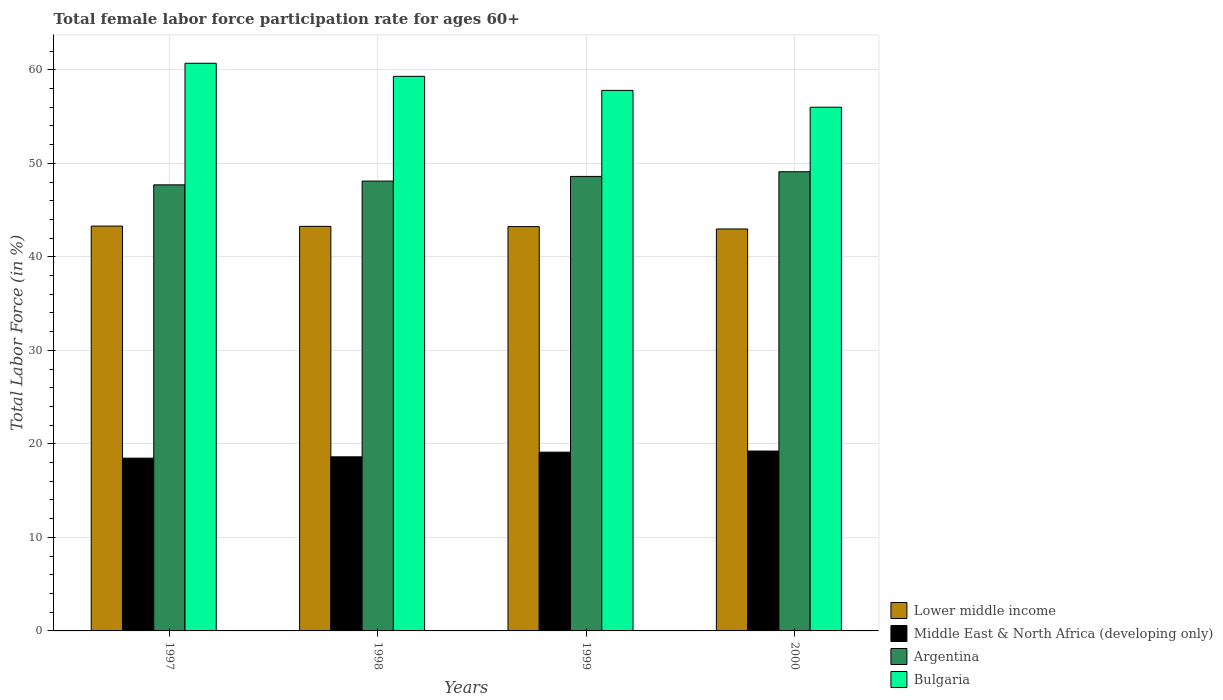How many different coloured bars are there?
Offer a very short reply. 4. Are the number of bars per tick equal to the number of legend labels?
Keep it short and to the point. Yes. How many bars are there on the 1st tick from the left?
Ensure brevity in your answer.  4. How many bars are there on the 4th tick from the right?
Ensure brevity in your answer.  4. What is the label of the 3rd group of bars from the left?
Ensure brevity in your answer.  1999. In how many cases, is the number of bars for a given year not equal to the number of legend labels?
Ensure brevity in your answer.  0. What is the female labor force participation rate in Middle East & North Africa (developing only) in 1998?
Keep it short and to the point. 18.62. Across all years, what is the maximum female labor force participation rate in Argentina?
Ensure brevity in your answer.  49.1. Across all years, what is the minimum female labor force participation rate in Lower middle income?
Ensure brevity in your answer.  42.98. In which year was the female labor force participation rate in Argentina minimum?
Ensure brevity in your answer.  1997. What is the total female labor force participation rate in Argentina in the graph?
Keep it short and to the point. 193.5. What is the difference between the female labor force participation rate in Lower middle income in 1998 and that in 2000?
Provide a succinct answer. 0.28. What is the difference between the female labor force participation rate in Argentina in 1998 and the female labor force participation rate in Lower middle income in 1997?
Provide a short and direct response. 4.81. What is the average female labor force participation rate in Bulgaria per year?
Offer a terse response. 58.45. In the year 2000, what is the difference between the female labor force participation rate in Bulgaria and female labor force participation rate in Lower middle income?
Ensure brevity in your answer.  13.02. In how many years, is the female labor force participation rate in Middle East & North Africa (developing only) greater than 16 %?
Offer a very short reply. 4. What is the ratio of the female labor force participation rate in Middle East & North Africa (developing only) in 1999 to that in 2000?
Make the answer very short. 0.99. What is the difference between the highest and the second highest female labor force participation rate in Argentina?
Provide a short and direct response. 0.5. What is the difference between the highest and the lowest female labor force participation rate in Argentina?
Offer a very short reply. 1.4. In how many years, is the female labor force participation rate in Lower middle income greater than the average female labor force participation rate in Lower middle income taken over all years?
Your answer should be very brief. 3. What does the 1st bar from the right in 1999 represents?
Ensure brevity in your answer.  Bulgaria. How many bars are there?
Provide a succinct answer. 16. Are all the bars in the graph horizontal?
Give a very brief answer. No. How many years are there in the graph?
Provide a succinct answer. 4. What is the difference between two consecutive major ticks on the Y-axis?
Offer a terse response. 10. Does the graph contain any zero values?
Give a very brief answer. No. Where does the legend appear in the graph?
Your answer should be very brief. Bottom right. How are the legend labels stacked?
Make the answer very short. Vertical. What is the title of the graph?
Keep it short and to the point. Total female labor force participation rate for ages 60+. Does "Vanuatu" appear as one of the legend labels in the graph?
Ensure brevity in your answer.  No. What is the label or title of the Y-axis?
Offer a very short reply. Total Labor Force (in %). What is the Total Labor Force (in %) in Lower middle income in 1997?
Your answer should be compact. 43.29. What is the Total Labor Force (in %) in Middle East & North Africa (developing only) in 1997?
Offer a very short reply. 18.47. What is the Total Labor Force (in %) of Argentina in 1997?
Your response must be concise. 47.7. What is the Total Labor Force (in %) in Bulgaria in 1997?
Offer a terse response. 60.7. What is the Total Labor Force (in %) of Lower middle income in 1998?
Provide a succinct answer. 43.26. What is the Total Labor Force (in %) in Middle East & North Africa (developing only) in 1998?
Offer a very short reply. 18.62. What is the Total Labor Force (in %) in Argentina in 1998?
Provide a succinct answer. 48.1. What is the Total Labor Force (in %) of Bulgaria in 1998?
Offer a very short reply. 59.3. What is the Total Labor Force (in %) of Lower middle income in 1999?
Provide a succinct answer. 43.23. What is the Total Labor Force (in %) in Middle East & North Africa (developing only) in 1999?
Keep it short and to the point. 19.11. What is the Total Labor Force (in %) in Argentina in 1999?
Offer a very short reply. 48.6. What is the Total Labor Force (in %) of Bulgaria in 1999?
Your answer should be very brief. 57.8. What is the Total Labor Force (in %) of Lower middle income in 2000?
Your response must be concise. 42.98. What is the Total Labor Force (in %) of Middle East & North Africa (developing only) in 2000?
Your response must be concise. 19.24. What is the Total Labor Force (in %) in Argentina in 2000?
Your response must be concise. 49.1. What is the Total Labor Force (in %) in Bulgaria in 2000?
Provide a short and direct response. 56. Across all years, what is the maximum Total Labor Force (in %) in Lower middle income?
Ensure brevity in your answer.  43.29. Across all years, what is the maximum Total Labor Force (in %) of Middle East & North Africa (developing only)?
Keep it short and to the point. 19.24. Across all years, what is the maximum Total Labor Force (in %) in Argentina?
Give a very brief answer. 49.1. Across all years, what is the maximum Total Labor Force (in %) in Bulgaria?
Ensure brevity in your answer.  60.7. Across all years, what is the minimum Total Labor Force (in %) in Lower middle income?
Keep it short and to the point. 42.98. Across all years, what is the minimum Total Labor Force (in %) in Middle East & North Africa (developing only)?
Provide a short and direct response. 18.47. Across all years, what is the minimum Total Labor Force (in %) of Argentina?
Provide a succinct answer. 47.7. What is the total Total Labor Force (in %) in Lower middle income in the graph?
Keep it short and to the point. 172.77. What is the total Total Labor Force (in %) of Middle East & North Africa (developing only) in the graph?
Give a very brief answer. 75.44. What is the total Total Labor Force (in %) of Argentina in the graph?
Your answer should be very brief. 193.5. What is the total Total Labor Force (in %) of Bulgaria in the graph?
Your answer should be very brief. 233.8. What is the difference between the Total Labor Force (in %) of Lower middle income in 1997 and that in 1998?
Give a very brief answer. 0.03. What is the difference between the Total Labor Force (in %) of Middle East & North Africa (developing only) in 1997 and that in 1998?
Keep it short and to the point. -0.14. What is the difference between the Total Labor Force (in %) of Lower middle income in 1997 and that in 1999?
Ensure brevity in your answer.  0.06. What is the difference between the Total Labor Force (in %) in Middle East & North Africa (developing only) in 1997 and that in 1999?
Your response must be concise. -0.64. What is the difference between the Total Labor Force (in %) of Argentina in 1997 and that in 1999?
Offer a very short reply. -0.9. What is the difference between the Total Labor Force (in %) in Bulgaria in 1997 and that in 1999?
Your answer should be very brief. 2.9. What is the difference between the Total Labor Force (in %) of Lower middle income in 1997 and that in 2000?
Provide a succinct answer. 0.31. What is the difference between the Total Labor Force (in %) of Middle East & North Africa (developing only) in 1997 and that in 2000?
Keep it short and to the point. -0.76. What is the difference between the Total Labor Force (in %) of Bulgaria in 1997 and that in 2000?
Keep it short and to the point. 4.7. What is the difference between the Total Labor Force (in %) of Lower middle income in 1998 and that in 1999?
Your answer should be very brief. 0.03. What is the difference between the Total Labor Force (in %) of Middle East & North Africa (developing only) in 1998 and that in 1999?
Offer a terse response. -0.5. What is the difference between the Total Labor Force (in %) in Bulgaria in 1998 and that in 1999?
Offer a terse response. 1.5. What is the difference between the Total Labor Force (in %) of Lower middle income in 1998 and that in 2000?
Give a very brief answer. 0.28. What is the difference between the Total Labor Force (in %) of Middle East & North Africa (developing only) in 1998 and that in 2000?
Ensure brevity in your answer.  -0.62. What is the difference between the Total Labor Force (in %) of Argentina in 1998 and that in 2000?
Your response must be concise. -1. What is the difference between the Total Labor Force (in %) in Lower middle income in 1999 and that in 2000?
Offer a terse response. 0.25. What is the difference between the Total Labor Force (in %) of Middle East & North Africa (developing only) in 1999 and that in 2000?
Give a very brief answer. -0.12. What is the difference between the Total Labor Force (in %) of Bulgaria in 1999 and that in 2000?
Offer a very short reply. 1.8. What is the difference between the Total Labor Force (in %) in Lower middle income in 1997 and the Total Labor Force (in %) in Middle East & North Africa (developing only) in 1998?
Your answer should be compact. 24.67. What is the difference between the Total Labor Force (in %) of Lower middle income in 1997 and the Total Labor Force (in %) of Argentina in 1998?
Your answer should be very brief. -4.81. What is the difference between the Total Labor Force (in %) of Lower middle income in 1997 and the Total Labor Force (in %) of Bulgaria in 1998?
Provide a succinct answer. -16.01. What is the difference between the Total Labor Force (in %) of Middle East & North Africa (developing only) in 1997 and the Total Labor Force (in %) of Argentina in 1998?
Make the answer very short. -29.63. What is the difference between the Total Labor Force (in %) in Middle East & North Africa (developing only) in 1997 and the Total Labor Force (in %) in Bulgaria in 1998?
Your response must be concise. -40.83. What is the difference between the Total Labor Force (in %) in Lower middle income in 1997 and the Total Labor Force (in %) in Middle East & North Africa (developing only) in 1999?
Offer a terse response. 24.18. What is the difference between the Total Labor Force (in %) of Lower middle income in 1997 and the Total Labor Force (in %) of Argentina in 1999?
Offer a terse response. -5.31. What is the difference between the Total Labor Force (in %) of Lower middle income in 1997 and the Total Labor Force (in %) of Bulgaria in 1999?
Offer a very short reply. -14.51. What is the difference between the Total Labor Force (in %) in Middle East & North Africa (developing only) in 1997 and the Total Labor Force (in %) in Argentina in 1999?
Provide a short and direct response. -30.13. What is the difference between the Total Labor Force (in %) of Middle East & North Africa (developing only) in 1997 and the Total Labor Force (in %) of Bulgaria in 1999?
Your answer should be compact. -39.33. What is the difference between the Total Labor Force (in %) in Argentina in 1997 and the Total Labor Force (in %) in Bulgaria in 1999?
Keep it short and to the point. -10.1. What is the difference between the Total Labor Force (in %) in Lower middle income in 1997 and the Total Labor Force (in %) in Middle East & North Africa (developing only) in 2000?
Provide a short and direct response. 24.05. What is the difference between the Total Labor Force (in %) of Lower middle income in 1997 and the Total Labor Force (in %) of Argentina in 2000?
Offer a very short reply. -5.81. What is the difference between the Total Labor Force (in %) of Lower middle income in 1997 and the Total Labor Force (in %) of Bulgaria in 2000?
Your answer should be compact. -12.71. What is the difference between the Total Labor Force (in %) of Middle East & North Africa (developing only) in 1997 and the Total Labor Force (in %) of Argentina in 2000?
Give a very brief answer. -30.63. What is the difference between the Total Labor Force (in %) in Middle East & North Africa (developing only) in 1997 and the Total Labor Force (in %) in Bulgaria in 2000?
Your response must be concise. -37.53. What is the difference between the Total Labor Force (in %) of Lower middle income in 1998 and the Total Labor Force (in %) of Middle East & North Africa (developing only) in 1999?
Ensure brevity in your answer.  24.15. What is the difference between the Total Labor Force (in %) in Lower middle income in 1998 and the Total Labor Force (in %) in Argentina in 1999?
Provide a short and direct response. -5.34. What is the difference between the Total Labor Force (in %) of Lower middle income in 1998 and the Total Labor Force (in %) of Bulgaria in 1999?
Offer a very short reply. -14.54. What is the difference between the Total Labor Force (in %) in Middle East & North Africa (developing only) in 1998 and the Total Labor Force (in %) in Argentina in 1999?
Offer a very short reply. -29.98. What is the difference between the Total Labor Force (in %) of Middle East & North Africa (developing only) in 1998 and the Total Labor Force (in %) of Bulgaria in 1999?
Make the answer very short. -39.18. What is the difference between the Total Labor Force (in %) in Lower middle income in 1998 and the Total Labor Force (in %) in Middle East & North Africa (developing only) in 2000?
Your answer should be compact. 24.03. What is the difference between the Total Labor Force (in %) of Lower middle income in 1998 and the Total Labor Force (in %) of Argentina in 2000?
Provide a succinct answer. -5.84. What is the difference between the Total Labor Force (in %) in Lower middle income in 1998 and the Total Labor Force (in %) in Bulgaria in 2000?
Offer a very short reply. -12.74. What is the difference between the Total Labor Force (in %) in Middle East & North Africa (developing only) in 1998 and the Total Labor Force (in %) in Argentina in 2000?
Give a very brief answer. -30.48. What is the difference between the Total Labor Force (in %) in Middle East & North Africa (developing only) in 1998 and the Total Labor Force (in %) in Bulgaria in 2000?
Offer a terse response. -37.38. What is the difference between the Total Labor Force (in %) in Argentina in 1998 and the Total Labor Force (in %) in Bulgaria in 2000?
Offer a very short reply. -7.9. What is the difference between the Total Labor Force (in %) in Lower middle income in 1999 and the Total Labor Force (in %) in Middle East & North Africa (developing only) in 2000?
Make the answer very short. 24. What is the difference between the Total Labor Force (in %) in Lower middle income in 1999 and the Total Labor Force (in %) in Argentina in 2000?
Keep it short and to the point. -5.87. What is the difference between the Total Labor Force (in %) in Lower middle income in 1999 and the Total Labor Force (in %) in Bulgaria in 2000?
Provide a short and direct response. -12.77. What is the difference between the Total Labor Force (in %) in Middle East & North Africa (developing only) in 1999 and the Total Labor Force (in %) in Argentina in 2000?
Your answer should be very brief. -29.99. What is the difference between the Total Labor Force (in %) of Middle East & North Africa (developing only) in 1999 and the Total Labor Force (in %) of Bulgaria in 2000?
Offer a terse response. -36.89. What is the average Total Labor Force (in %) in Lower middle income per year?
Make the answer very short. 43.19. What is the average Total Labor Force (in %) of Middle East & North Africa (developing only) per year?
Your answer should be very brief. 18.86. What is the average Total Labor Force (in %) in Argentina per year?
Your answer should be very brief. 48.38. What is the average Total Labor Force (in %) in Bulgaria per year?
Your response must be concise. 58.45. In the year 1997, what is the difference between the Total Labor Force (in %) in Lower middle income and Total Labor Force (in %) in Middle East & North Africa (developing only)?
Keep it short and to the point. 24.82. In the year 1997, what is the difference between the Total Labor Force (in %) in Lower middle income and Total Labor Force (in %) in Argentina?
Provide a succinct answer. -4.41. In the year 1997, what is the difference between the Total Labor Force (in %) of Lower middle income and Total Labor Force (in %) of Bulgaria?
Your response must be concise. -17.41. In the year 1997, what is the difference between the Total Labor Force (in %) in Middle East & North Africa (developing only) and Total Labor Force (in %) in Argentina?
Your answer should be very brief. -29.23. In the year 1997, what is the difference between the Total Labor Force (in %) of Middle East & North Africa (developing only) and Total Labor Force (in %) of Bulgaria?
Offer a very short reply. -42.23. In the year 1997, what is the difference between the Total Labor Force (in %) of Argentina and Total Labor Force (in %) of Bulgaria?
Provide a short and direct response. -13. In the year 1998, what is the difference between the Total Labor Force (in %) of Lower middle income and Total Labor Force (in %) of Middle East & North Africa (developing only)?
Provide a succinct answer. 24.64. In the year 1998, what is the difference between the Total Labor Force (in %) of Lower middle income and Total Labor Force (in %) of Argentina?
Offer a terse response. -4.84. In the year 1998, what is the difference between the Total Labor Force (in %) in Lower middle income and Total Labor Force (in %) in Bulgaria?
Offer a terse response. -16.04. In the year 1998, what is the difference between the Total Labor Force (in %) of Middle East & North Africa (developing only) and Total Labor Force (in %) of Argentina?
Your response must be concise. -29.48. In the year 1998, what is the difference between the Total Labor Force (in %) in Middle East & North Africa (developing only) and Total Labor Force (in %) in Bulgaria?
Make the answer very short. -40.68. In the year 1998, what is the difference between the Total Labor Force (in %) in Argentina and Total Labor Force (in %) in Bulgaria?
Make the answer very short. -11.2. In the year 1999, what is the difference between the Total Labor Force (in %) in Lower middle income and Total Labor Force (in %) in Middle East & North Africa (developing only)?
Your answer should be very brief. 24.12. In the year 1999, what is the difference between the Total Labor Force (in %) of Lower middle income and Total Labor Force (in %) of Argentina?
Ensure brevity in your answer.  -5.37. In the year 1999, what is the difference between the Total Labor Force (in %) in Lower middle income and Total Labor Force (in %) in Bulgaria?
Provide a short and direct response. -14.57. In the year 1999, what is the difference between the Total Labor Force (in %) of Middle East & North Africa (developing only) and Total Labor Force (in %) of Argentina?
Make the answer very short. -29.49. In the year 1999, what is the difference between the Total Labor Force (in %) in Middle East & North Africa (developing only) and Total Labor Force (in %) in Bulgaria?
Ensure brevity in your answer.  -38.69. In the year 2000, what is the difference between the Total Labor Force (in %) of Lower middle income and Total Labor Force (in %) of Middle East & North Africa (developing only)?
Provide a succinct answer. 23.75. In the year 2000, what is the difference between the Total Labor Force (in %) of Lower middle income and Total Labor Force (in %) of Argentina?
Ensure brevity in your answer.  -6.12. In the year 2000, what is the difference between the Total Labor Force (in %) of Lower middle income and Total Labor Force (in %) of Bulgaria?
Make the answer very short. -13.02. In the year 2000, what is the difference between the Total Labor Force (in %) in Middle East & North Africa (developing only) and Total Labor Force (in %) in Argentina?
Provide a short and direct response. -29.86. In the year 2000, what is the difference between the Total Labor Force (in %) of Middle East & North Africa (developing only) and Total Labor Force (in %) of Bulgaria?
Your answer should be compact. -36.76. In the year 2000, what is the difference between the Total Labor Force (in %) in Argentina and Total Labor Force (in %) in Bulgaria?
Give a very brief answer. -6.9. What is the ratio of the Total Labor Force (in %) in Lower middle income in 1997 to that in 1998?
Offer a very short reply. 1. What is the ratio of the Total Labor Force (in %) of Argentina in 1997 to that in 1998?
Keep it short and to the point. 0.99. What is the ratio of the Total Labor Force (in %) of Bulgaria in 1997 to that in 1998?
Give a very brief answer. 1.02. What is the ratio of the Total Labor Force (in %) in Lower middle income in 1997 to that in 1999?
Provide a short and direct response. 1. What is the ratio of the Total Labor Force (in %) of Middle East & North Africa (developing only) in 1997 to that in 1999?
Keep it short and to the point. 0.97. What is the ratio of the Total Labor Force (in %) in Argentina in 1997 to that in 1999?
Offer a terse response. 0.98. What is the ratio of the Total Labor Force (in %) in Bulgaria in 1997 to that in 1999?
Provide a short and direct response. 1.05. What is the ratio of the Total Labor Force (in %) in Middle East & North Africa (developing only) in 1997 to that in 2000?
Your response must be concise. 0.96. What is the ratio of the Total Labor Force (in %) in Argentina in 1997 to that in 2000?
Your answer should be very brief. 0.97. What is the ratio of the Total Labor Force (in %) of Bulgaria in 1997 to that in 2000?
Offer a very short reply. 1.08. What is the ratio of the Total Labor Force (in %) in Argentina in 1998 to that in 1999?
Your answer should be compact. 0.99. What is the ratio of the Total Labor Force (in %) in Middle East & North Africa (developing only) in 1998 to that in 2000?
Offer a terse response. 0.97. What is the ratio of the Total Labor Force (in %) of Argentina in 1998 to that in 2000?
Your response must be concise. 0.98. What is the ratio of the Total Labor Force (in %) in Bulgaria in 1998 to that in 2000?
Give a very brief answer. 1.06. What is the ratio of the Total Labor Force (in %) in Lower middle income in 1999 to that in 2000?
Your response must be concise. 1.01. What is the ratio of the Total Labor Force (in %) of Middle East & North Africa (developing only) in 1999 to that in 2000?
Make the answer very short. 0.99. What is the ratio of the Total Labor Force (in %) in Bulgaria in 1999 to that in 2000?
Provide a succinct answer. 1.03. What is the difference between the highest and the second highest Total Labor Force (in %) in Lower middle income?
Your response must be concise. 0.03. What is the difference between the highest and the second highest Total Labor Force (in %) in Middle East & North Africa (developing only)?
Your answer should be very brief. 0.12. What is the difference between the highest and the second highest Total Labor Force (in %) in Argentina?
Ensure brevity in your answer.  0.5. What is the difference between the highest and the lowest Total Labor Force (in %) in Lower middle income?
Your response must be concise. 0.31. What is the difference between the highest and the lowest Total Labor Force (in %) of Middle East & North Africa (developing only)?
Your answer should be very brief. 0.76. What is the difference between the highest and the lowest Total Labor Force (in %) in Bulgaria?
Ensure brevity in your answer.  4.7. 